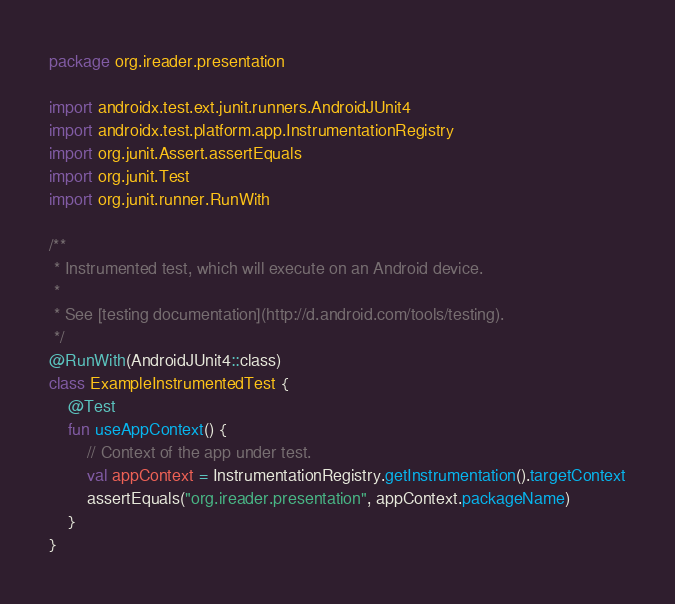Convert code to text. <code><loc_0><loc_0><loc_500><loc_500><_Kotlin_>package org.ireader.presentation

import androidx.test.ext.junit.runners.AndroidJUnit4
import androidx.test.platform.app.InstrumentationRegistry
import org.junit.Assert.assertEquals
import org.junit.Test
import org.junit.runner.RunWith

/**
 * Instrumented test, which will execute on an Android device.
 *
 * See [testing documentation](http://d.android.com/tools/testing).
 */
@RunWith(AndroidJUnit4::class)
class ExampleInstrumentedTest {
    @Test
    fun useAppContext() {
        // Context of the app under test.
        val appContext = InstrumentationRegistry.getInstrumentation().targetContext
        assertEquals("org.ireader.presentation", appContext.packageName)
    }
}
</code> 